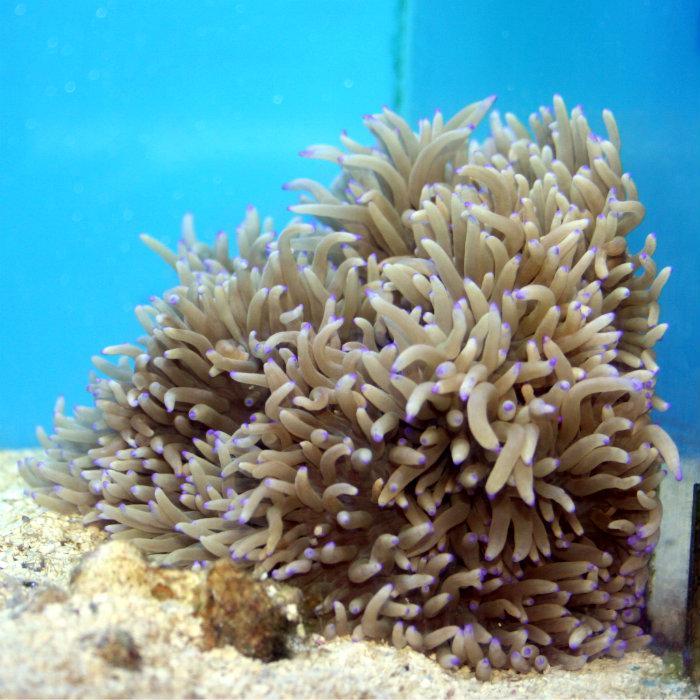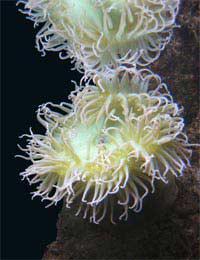The first image is the image on the left, the second image is the image on the right. Considering the images on both sides, is "An image shows a neutral-colored anemone with sky blue background." valid? Answer yes or no. Yes. 